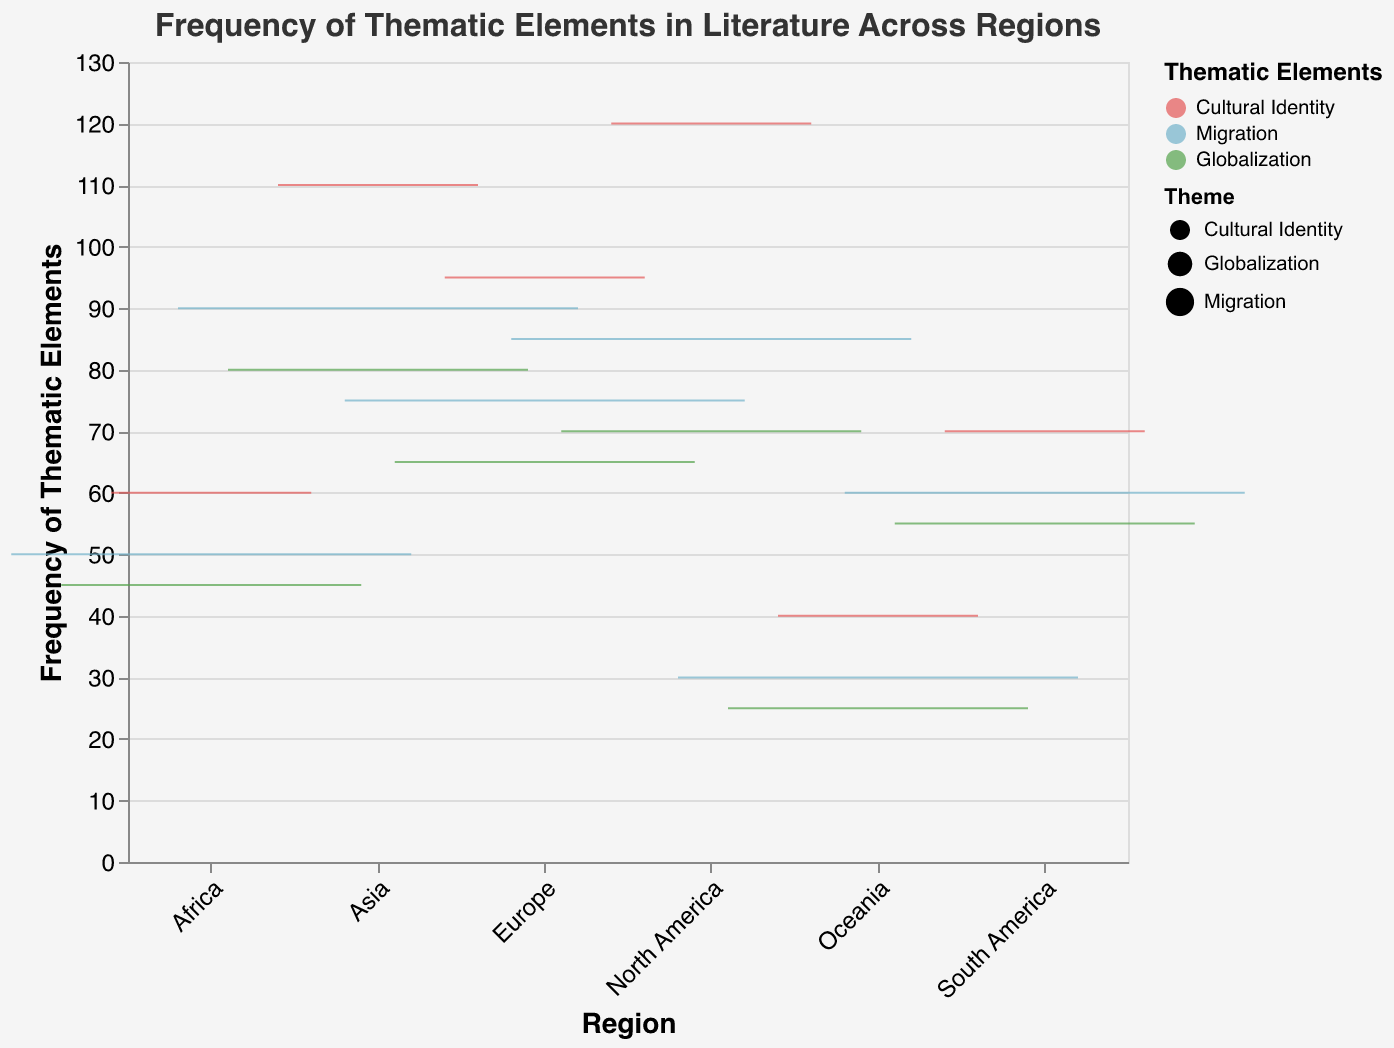What's the frequency of Cultural Identity in North America as depicted in the figure? To find the frequency, locate the relevant data point labeled "Cultural Identity" under the "North America" region on the x-axis. Read the corresponding y-axis value, which represents the frequency.
Answer: 120 Which region has the highest frequency of thematic elements? To determine the region with the highest frequency, observe the topmost boxplot for each region on the graph. The highest topmost box indicates the highest frequency, which is found in North America for Cultural Identity.
Answer: North America Compare the frequencies of Migration and Globalization themes in Asia. Which one is higher? Locate the thematic elements for "Migration" and "Globalization" under the "Asia" region on the x-axis. Compare the y-axis values for both themes. Migration has a frequency of 90, and Globalization has a frequency of 80.
Answer: Migration What is the range of frequencies for the "Cultural Identity" theme across all regions? Identify the minimum and maximum y-axis values for the "Cultural Identity" boxes in all regions. The minimum value is found in Oceania (40), and the maximum is in North America (120).
Answer: 40-120 How does the frequency of Globalization in Europe compare with that in South America? Find the data points for "Globalization" under the "Europe" and "South America" regions on the x-axis. Check the corresponding y-axis values, which are 65 for Europe and 55 for South America.
Answer: Higher in Europe How many thematic elements are depicted for each region in the figure? Observe the legend indicating the thematic elements and count them. Each region has three thematic elements: Cultural Identity, Migration, and Globalization.
Answer: 3 themes What is the median frequency of thematic elements in Oceania? Determine the median line within each box. The thematic elements in Oceania have frequencies of 40 (Cultural Identity), 30 (Migration), and 25 (Globalization). The median frequency is 30.
Answer: 30 Which two regions have the closest frequencies for the Globalization theme? Compare the y-axis values of the "Globalization" theme across all regions visually. Europe and Asia have relatively close frequencies, being 65 and 80, respectively.
Answer: Europe and Asia What is the average frequency of the Migration theme across all regions? Identify the frequencies for "Migration" across all regions: North America (85), Europe (75), Asia (90), Africa (50), South America (60), and Oceania (30). Sum these (85+75+90+50+60+30 = 390) and divide by the number of regions (6) to get the average.
Answer: 65 Which theme exhibits the most consistent frequency across different regions? Look for the thematic elements where the height of the boxes varies the least across different regions. The boxes for "Globalization" show the least variation in heights.
Answer: Globalization 